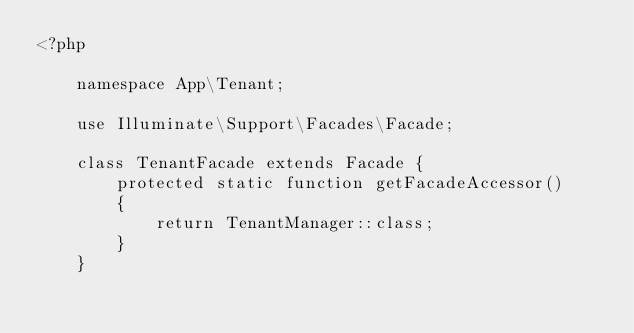Convert code to text. <code><loc_0><loc_0><loc_500><loc_500><_PHP_><?php

    namespace App\Tenant;

    use Illuminate\Support\Facades\Facade;

    class TenantFacade extends Facade {
        protected static function getFacadeAccessor()
        {
            return TenantManager::class;
        }
    }
</code> 